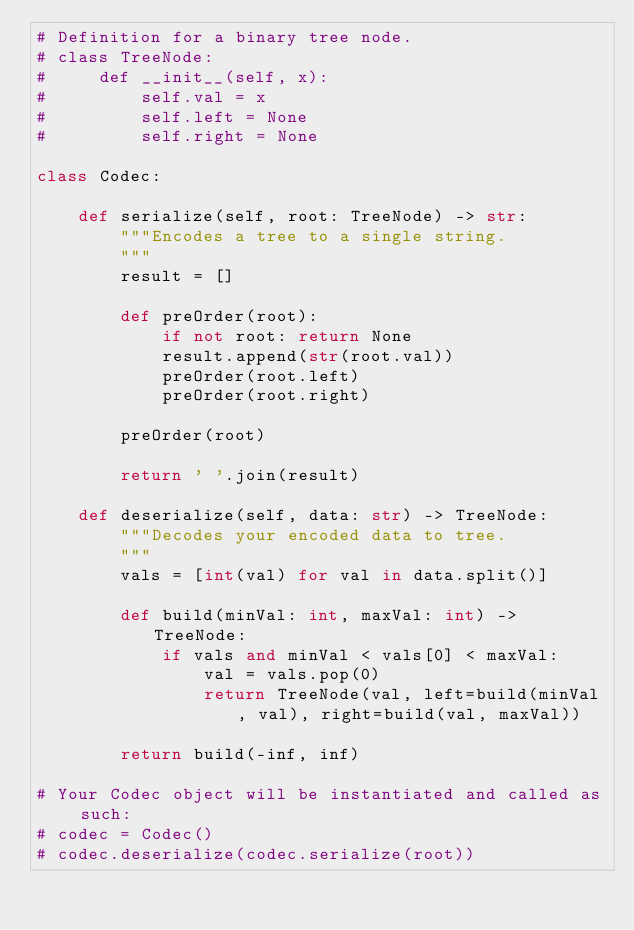<code> <loc_0><loc_0><loc_500><loc_500><_Python_># Definition for a binary tree node.
# class TreeNode:
#     def __init__(self, x):
#         self.val = x
#         self.left = None
#         self.right = None

class Codec:

    def serialize(self, root: TreeNode) -> str:
        """Encodes a tree to a single string.
        """
        result = []

        def preOrder(root):
            if not root: return None
            result.append(str(root.val))
            preOrder(root.left)
            preOrder(root.right)

        preOrder(root)

        return ' '.join(result)

    def deserialize(self, data: str) -> TreeNode:
        """Decodes your encoded data to tree.
        """
        vals = [int(val) for val in data.split()]

        def build(minVal: int, maxVal: int) -> TreeNode:
            if vals and minVal < vals[0] < maxVal:
                val = vals.pop(0)
                return TreeNode(val, left=build(minVal, val), right=build(val, maxVal))

        return build(-inf, inf)

# Your Codec object will be instantiated and called as such:
# codec = Codec()
# codec.deserialize(codec.serialize(root))
</code> 